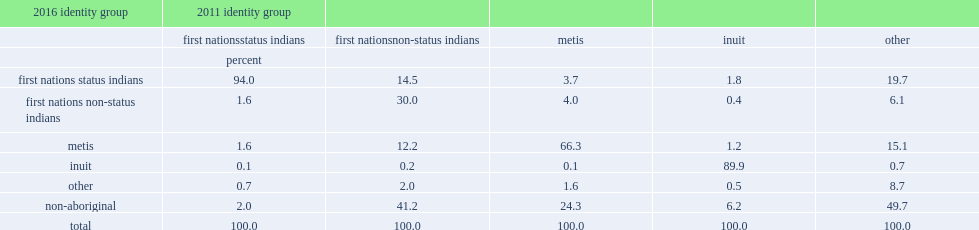Among those who identified as first nations status indians in 2011, what is the percentage of provided the same response in 2016? 94.0. Of those who reported being metis in 2011, what the percentage reported in 2016? 66.3. Of those who reported being metis in 2011, what is the percentage of identified as non-aboriginal in 2016? 24.3. What is the percentage moved into the first nations status indian population in 2011 identify group? 14.5. What percentage identified as metis of first nations non-status indians population in 2011 identify group? 12.2. Can you give me this table as a dict? {'header': ['2016 identity group', '2011 identity group', '', '', '', ''], 'rows': [['', 'first nationsstatus indians', 'first nationsnon-status indians', 'metis', 'inuit', 'other'], ['', 'percent', '', '', '', ''], ['first nations status indians', '94.0', '14.5', '3.7', '1.8', '19.7'], ['first nations non-status indians', '1.6', '30.0', '4.0', '0.4', '6.1'], ['metis', '1.6', '12.2', '66.3', '1.2', '15.1'], ['inuit', '0.1', '0.2', '0.1', '89.9', '0.7'], ['other', '0.7', '2.0', '1.6', '0.5', '8.7'], ['non-aboriginal', '2.0', '41.2', '24.3', '6.2', '49.7'], ['total', '100.0', '100.0', '100.0', '100.0', '100.0']]} 